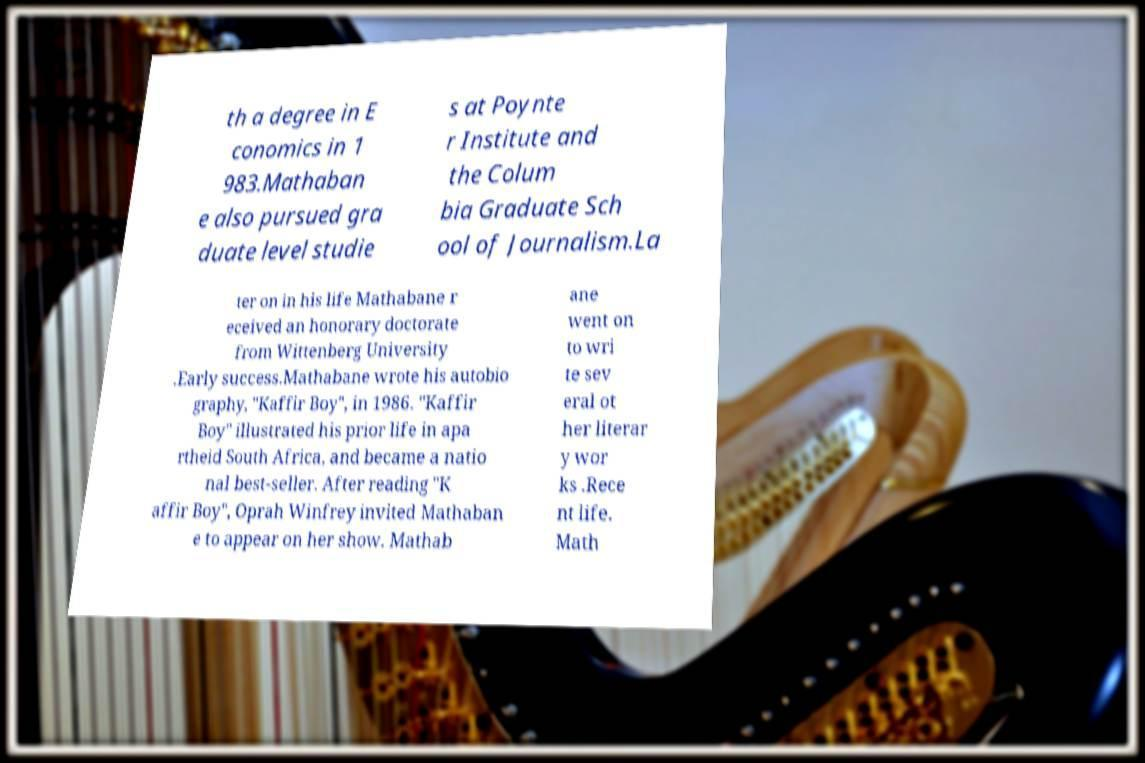Could you extract and type out the text from this image? th a degree in E conomics in 1 983.Mathaban e also pursued gra duate level studie s at Poynte r Institute and the Colum bia Graduate Sch ool of Journalism.La ter on in his life Mathabane r eceived an honorary doctorate from Wittenberg University .Early success.Mathabane wrote his autobio graphy, "Kaffir Boy", in 1986. "Kaffir Boy" illustrated his prior life in apa rtheid South Africa, and became a natio nal best-seller. After reading "K affir Boy", Oprah Winfrey invited Mathaban e to appear on her show. Mathab ane went on to wri te sev eral ot her literar y wor ks .Rece nt life. Math 